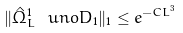<formula> <loc_0><loc_0><loc_500><loc_500>\| \hat { \Omega } ^ { 1 } _ { L } \ u n o { D _ { 1 } } \| _ { 1 } \leq e ^ { - C L ^ { 3 } }</formula> 